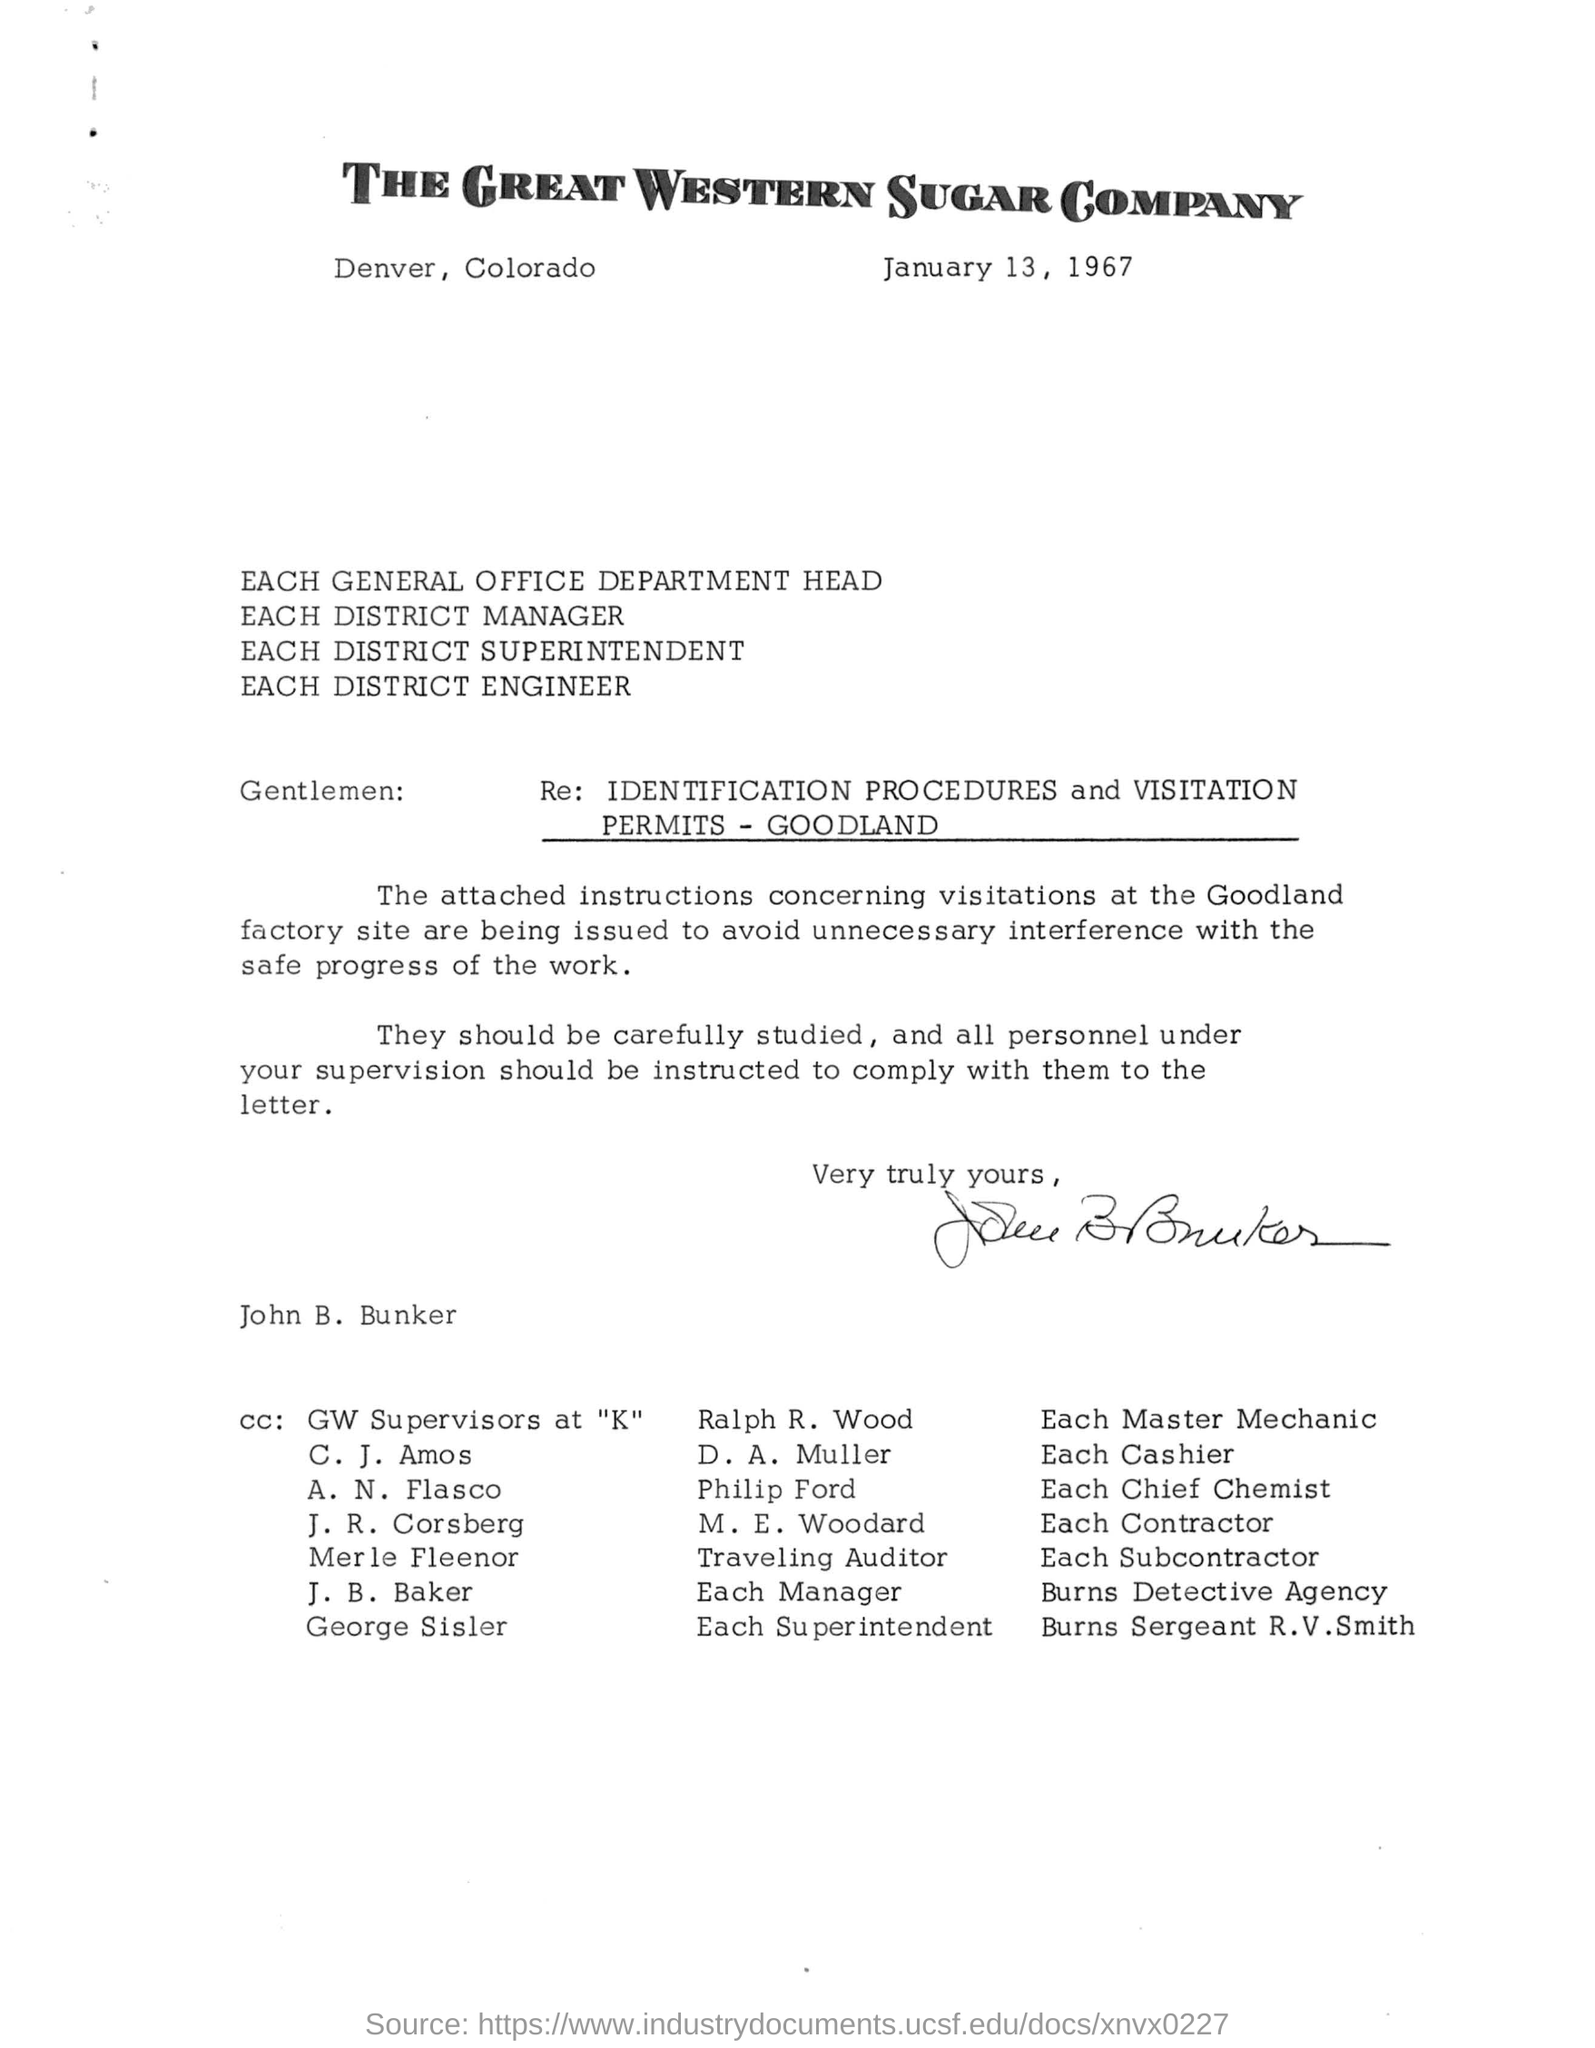Outline some significant characteristics in this image. The date mentioned in the letter is January 13, 1967. 